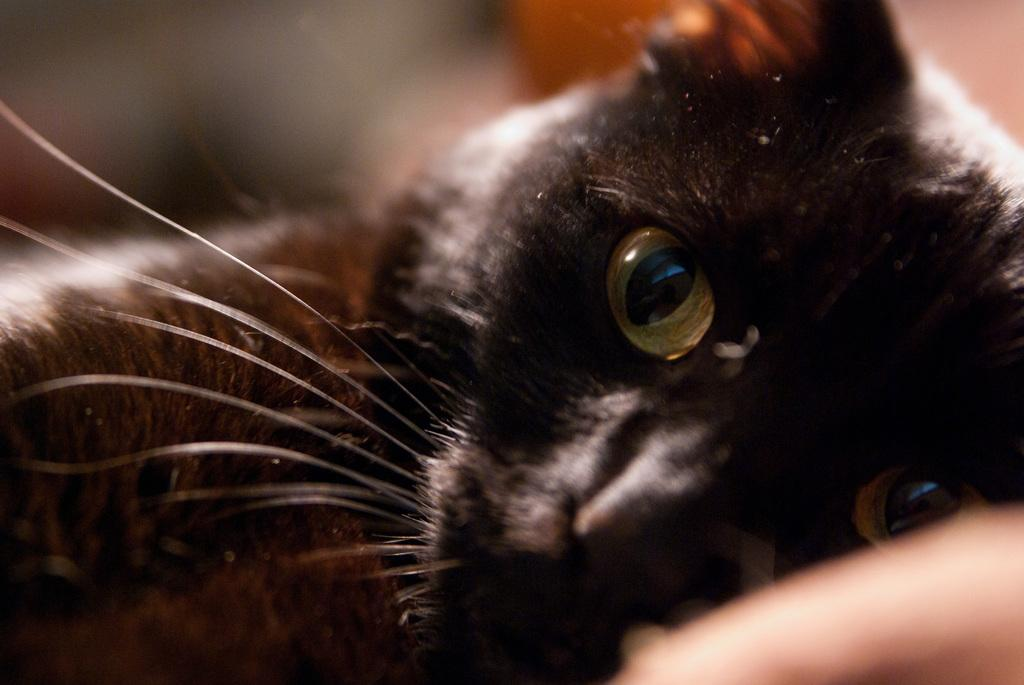What type of animal is in the image? There is a black color cat in the image. Where is the cat located in the image? The cat is in the middle of the image. What type of disgust can be seen on the cat's face in the image? There is no indication of disgust on the cat's face in the image, as the cat's facial expression is not visible. 